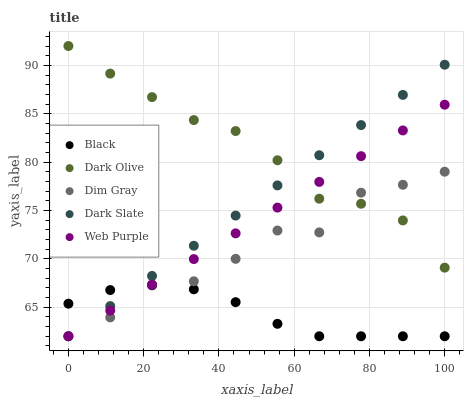Does Black have the minimum area under the curve?
Answer yes or no. Yes. Does Dark Olive have the maximum area under the curve?
Answer yes or no. Yes. Does Dim Gray have the minimum area under the curve?
Answer yes or no. No. Does Dim Gray have the maximum area under the curve?
Answer yes or no. No. Is Dark Slate the smoothest?
Answer yes or no. Yes. Is Dim Gray the roughest?
Answer yes or no. Yes. Is Dark Olive the smoothest?
Answer yes or no. No. Is Dark Olive the roughest?
Answer yes or no. No. Does Dark Slate have the lowest value?
Answer yes or no. Yes. Does Dark Olive have the lowest value?
Answer yes or no. No. Does Dark Olive have the highest value?
Answer yes or no. Yes. Does Dim Gray have the highest value?
Answer yes or no. No. Is Black less than Dark Olive?
Answer yes or no. Yes. Is Dark Olive greater than Black?
Answer yes or no. Yes. Does Web Purple intersect Dark Olive?
Answer yes or no. Yes. Is Web Purple less than Dark Olive?
Answer yes or no. No. Is Web Purple greater than Dark Olive?
Answer yes or no. No. Does Black intersect Dark Olive?
Answer yes or no. No. 